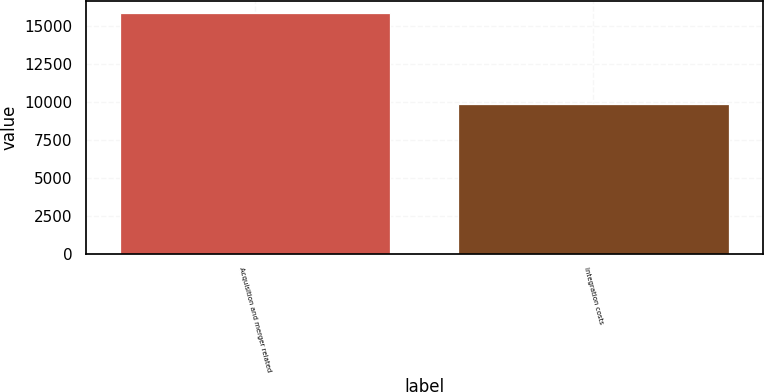Convert chart. <chart><loc_0><loc_0><loc_500><loc_500><bar_chart><fcel>Acquisition and merger related<fcel>Integration costs<nl><fcel>15875<fcel>9901<nl></chart> 